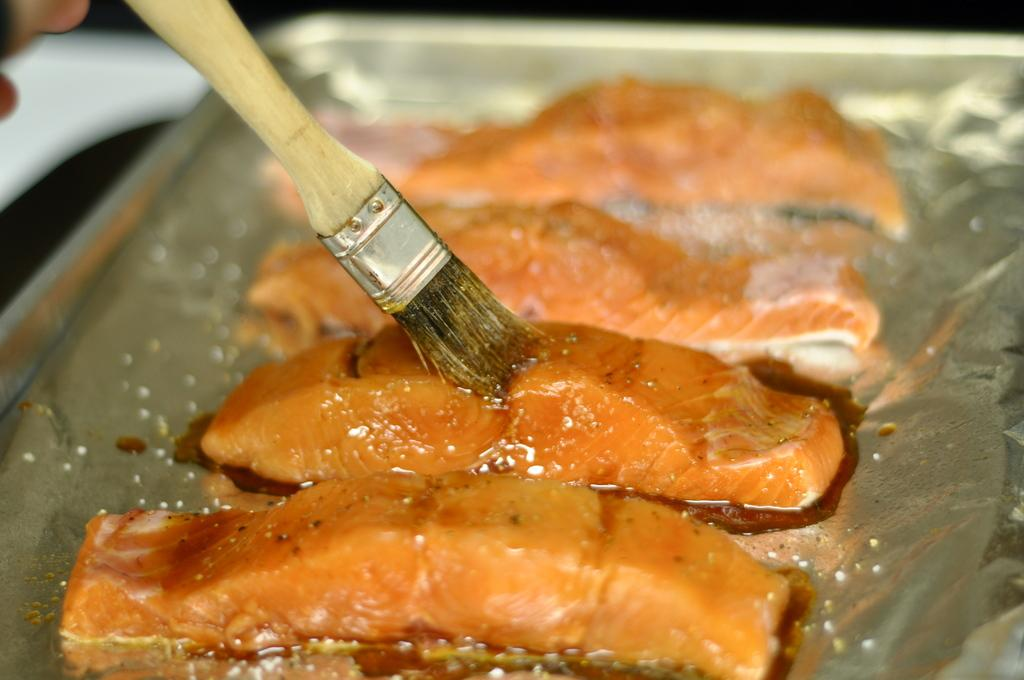What is on the tray in the image? There are meat slices on a tray in the image. Can you describe any additional details about the meat slices? There is a brush on a slice of meat in the image. What type of day is depicted in the image? The image does not depict a day; it is a still image of meat slices on a tray with a brush on one of the slices. 